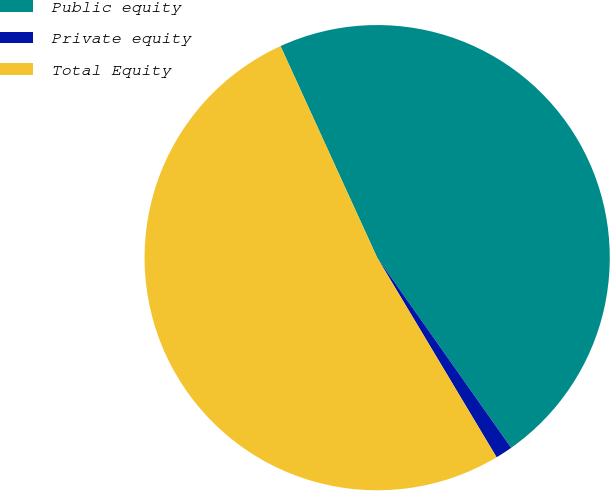Convert chart to OTSL. <chart><loc_0><loc_0><loc_500><loc_500><pie_chart><fcel>Public equity<fcel>Private equity<fcel>Total Equity<nl><fcel>47.05%<fcel>1.19%<fcel>51.76%<nl></chart> 